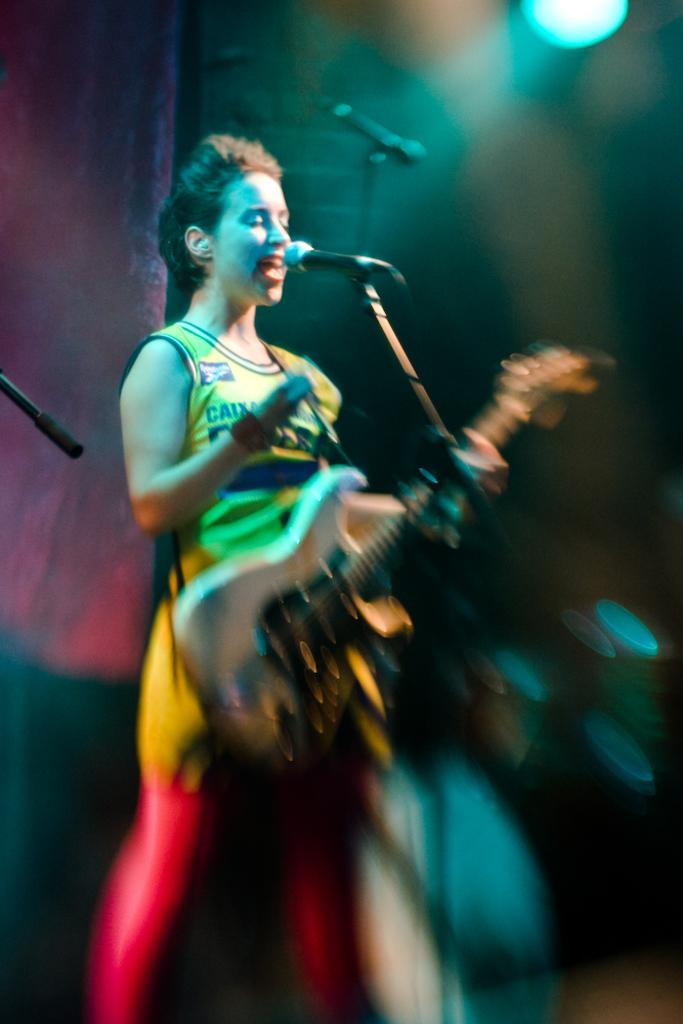Who is the main subject in the image? There is a woman in the image. What is the woman wearing? The woman is wearing a yellow dress. What is the woman holding in the image? The woman is holding a guitar. What activity is the woman engaged in? The woman is singing through a mic. What type of feather can be seen in the woman's hair in the image? There is no feather visible in the woman's hair in the image. What kind of powder is the woman applying to her face in the image? There is no powder or makeup application visible in the image. 